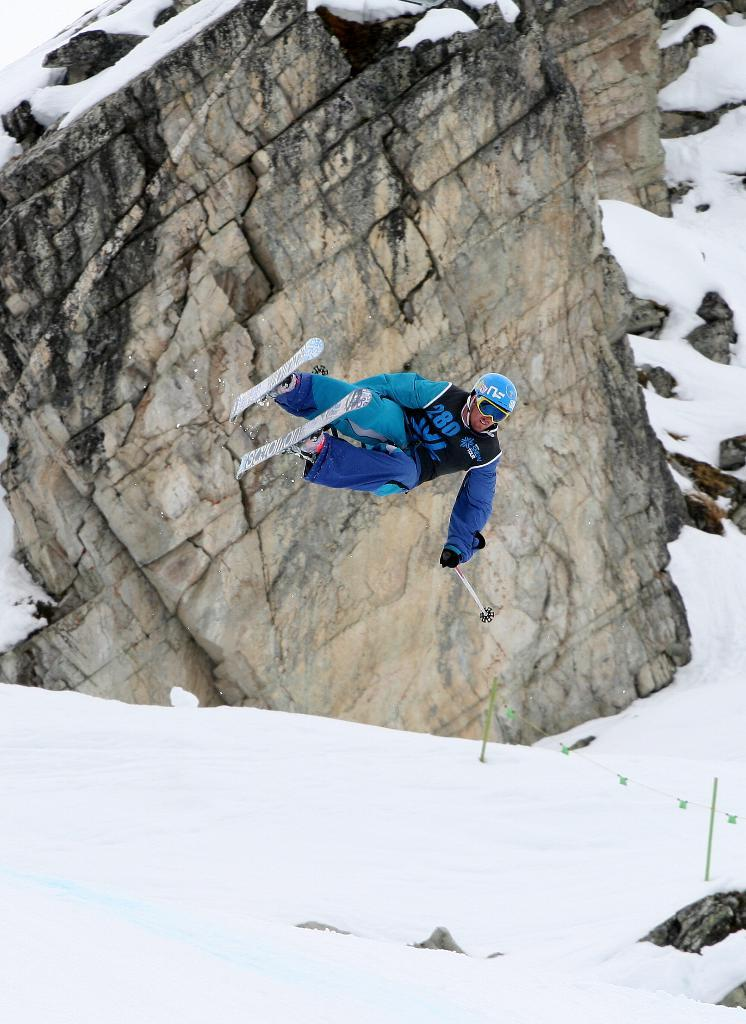What is the person in the image doing? The person is jumping with ski boards. What equipment is the person using while jumping? The person is holding a ski pole. What type of surface is under the person? There is snow under the person. What can be seen in the background of the image? There is a hill behind the person. What type of polish is the person applying to their ski boards in the image? There is no indication in the image that the person is applying any polish to their ski boards. 